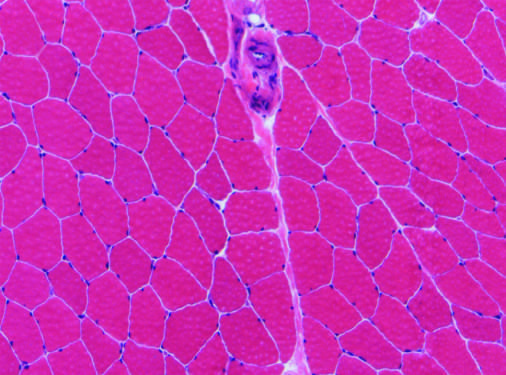does enal glomerulus showing markedly have relatively uniform polygonal myofibers with peripherally placed nuclei that are tightly packed together into fascicles separated by scant connective tissue?
Answer the question using a single word or phrase. No 